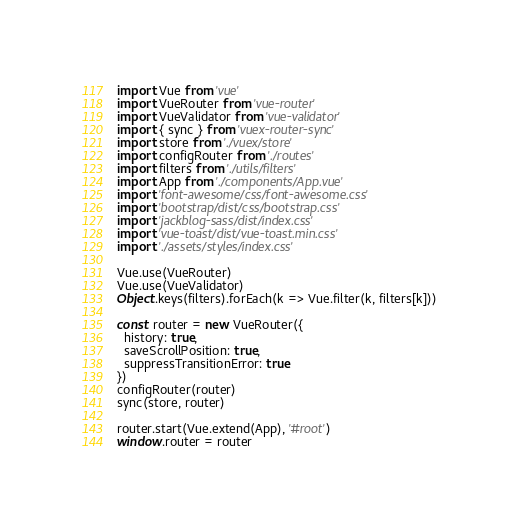Convert code to text. <code><loc_0><loc_0><loc_500><loc_500><_JavaScript_>import Vue from 'vue'
import VueRouter from 'vue-router'
import VueValidator from 'vue-validator'
import { sync } from 'vuex-router-sync'
import store from './vuex/store'
import configRouter from './routes'
import filters from './utils/filters'
import App from './components/App.vue'
import 'font-awesome/css/font-awesome.css'
import 'bootstrap/dist/css/bootstrap.css'
import 'jackblog-sass/dist/index.css'
import 'vue-toast/dist/vue-toast.min.css'
import './assets/styles/index.css'

Vue.use(VueRouter)
Vue.use(VueValidator)
Object.keys(filters).forEach(k => Vue.filter(k, filters[k]))

const router = new VueRouter({
  history: true,
  saveScrollPosition: true,
  suppressTransitionError: true
})
configRouter(router)
sync(store, router)

router.start(Vue.extend(App), '#root')
window.router = router</code> 